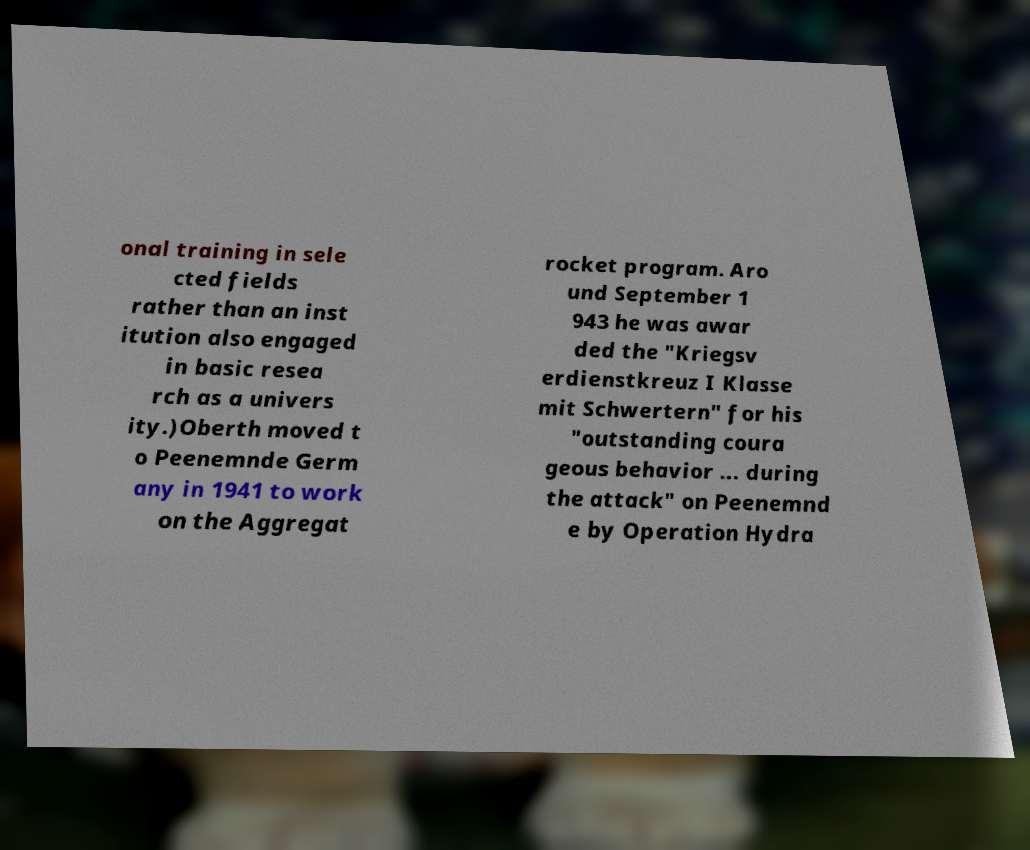For documentation purposes, I need the text within this image transcribed. Could you provide that? onal training in sele cted fields rather than an inst itution also engaged in basic resea rch as a univers ity.)Oberth moved t o Peenemnde Germ any in 1941 to work on the Aggregat rocket program. Aro und September 1 943 he was awar ded the "Kriegsv erdienstkreuz I Klasse mit Schwertern" for his "outstanding coura geous behavior ... during the attack" on Peenemnd e by Operation Hydra 